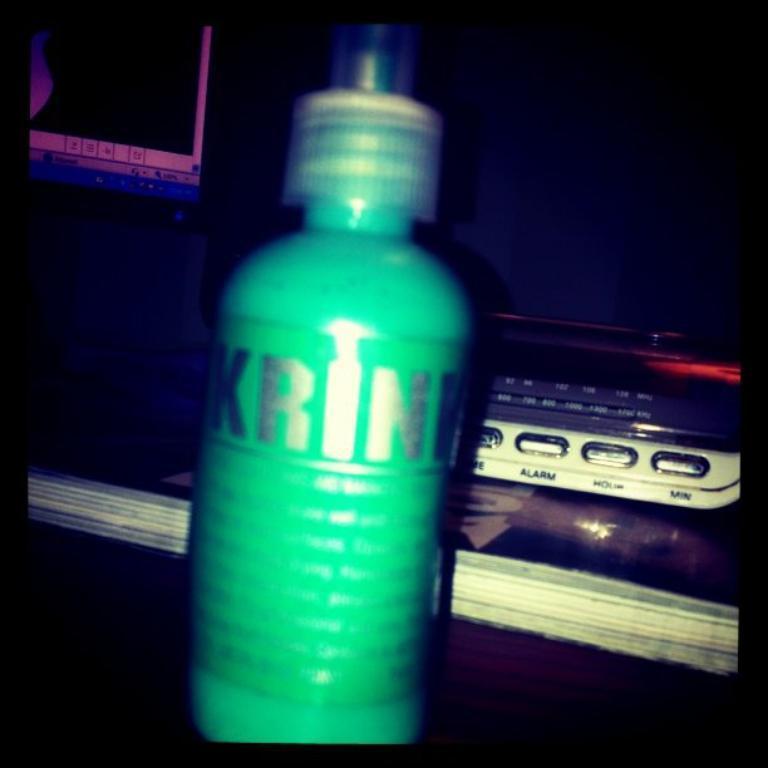Can you describe this image briefly? There is a green bottle which has something written on it. 